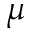Convert formula to latex. <formula><loc_0><loc_0><loc_500><loc_500>\mu</formula> 